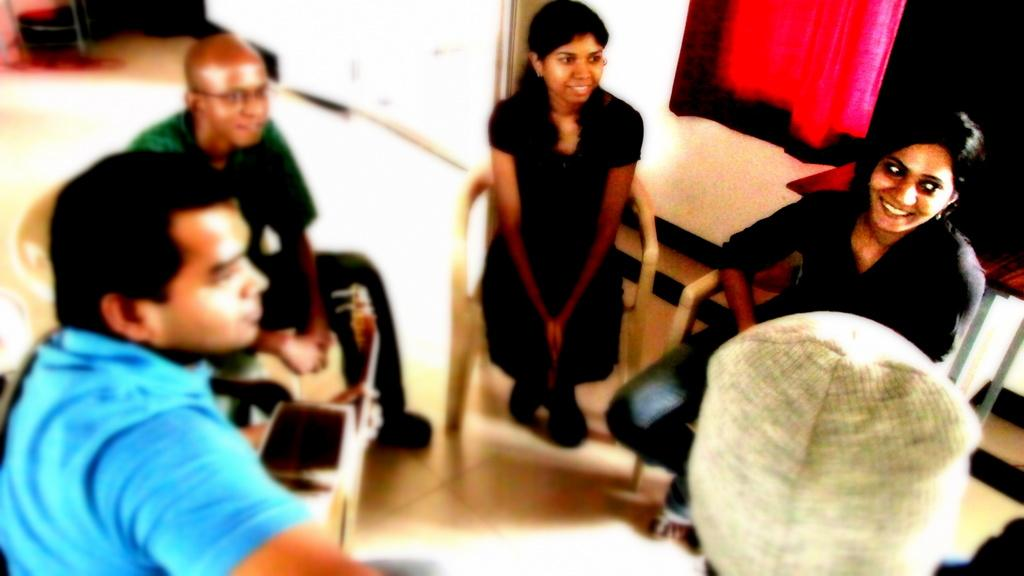What are the people in the image doing? The people in the image are sitting on chairs. Where was the image taken? The image was taken inside a room. What can be seen on the wall on the right side of the image? There is a curtain on the wall on the right side of the image. What type of bushes can be seen growing outside the window in the image? There is no window or bushes visible in the image; it was taken inside a room with a curtain on the wall. 